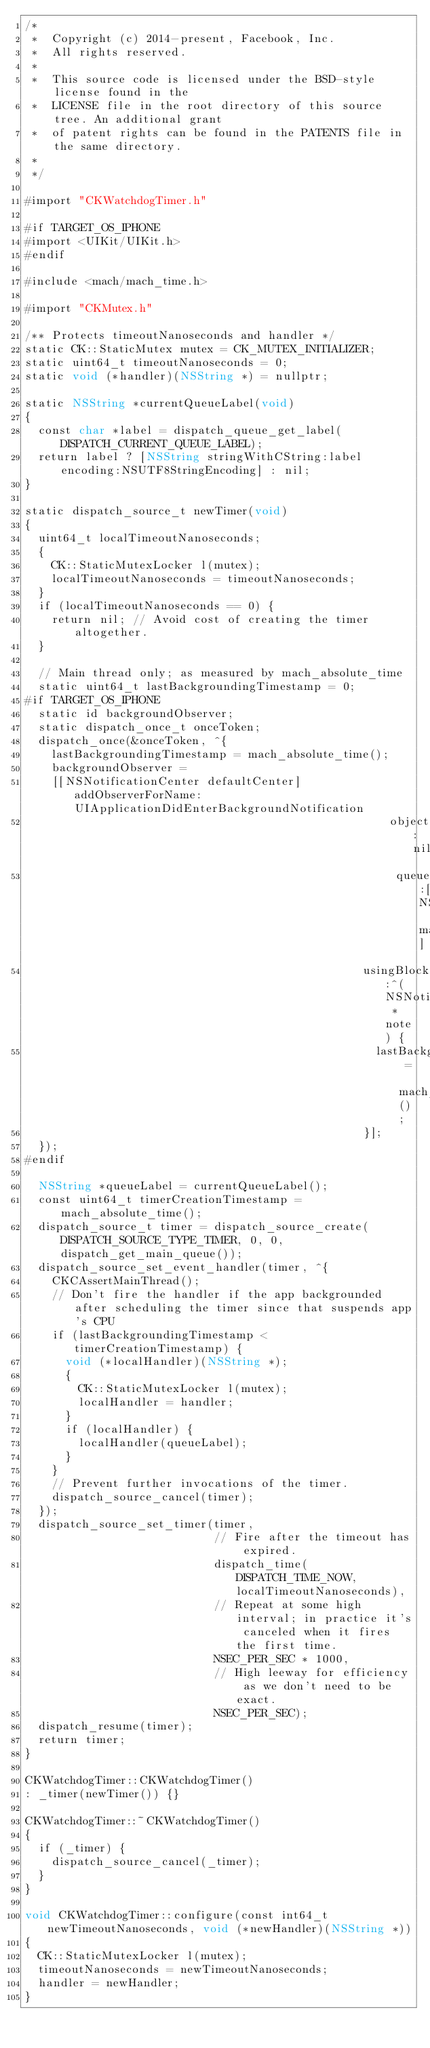<code> <loc_0><loc_0><loc_500><loc_500><_ObjectiveC_>/*
 *  Copyright (c) 2014-present, Facebook, Inc.
 *  All rights reserved.
 *
 *  This source code is licensed under the BSD-style license found in the
 *  LICENSE file in the root directory of this source tree. An additional grant
 *  of patent rights can be found in the PATENTS file in the same directory.
 *
 */

#import "CKWatchdogTimer.h"

#if TARGET_OS_IPHONE
#import <UIKit/UIKit.h>
#endif

#include <mach/mach_time.h>

#import "CKMutex.h"

/** Protects timeoutNanoseconds and handler */
static CK::StaticMutex mutex = CK_MUTEX_INITIALIZER;
static uint64_t timeoutNanoseconds = 0;
static void (*handler)(NSString *) = nullptr;

static NSString *currentQueueLabel(void)
{
  const char *label = dispatch_queue_get_label(DISPATCH_CURRENT_QUEUE_LABEL);
  return label ? [NSString stringWithCString:label encoding:NSUTF8StringEncoding] : nil;
}

static dispatch_source_t newTimer(void)
{
  uint64_t localTimeoutNanoseconds;
  {
    CK::StaticMutexLocker l(mutex);
    localTimeoutNanoseconds = timeoutNanoseconds;
  }
  if (localTimeoutNanoseconds == 0) {
    return nil; // Avoid cost of creating the timer altogether.
  }

  // Main thread only; as measured by mach_absolute_time
  static uint64_t lastBackgroundingTimestamp = 0;
#if TARGET_OS_IPHONE
  static id backgroundObserver;
  static dispatch_once_t onceToken;
  dispatch_once(&onceToken, ^{
    lastBackgroundingTimestamp = mach_absolute_time();
    backgroundObserver =
    [[NSNotificationCenter defaultCenter] addObserverForName:UIApplicationDidEnterBackgroundNotification
                                                      object:nil
                                                       queue:[NSOperationQueue mainQueue]
                                                  usingBlock:^(NSNotification *note) {
                                                    lastBackgroundingTimestamp = mach_absolute_time();
                                                  }];
  });
#endif
  
  NSString *queueLabel = currentQueueLabel();
  const uint64_t timerCreationTimestamp = mach_absolute_time();
  dispatch_source_t timer = dispatch_source_create(DISPATCH_SOURCE_TYPE_TIMER, 0, 0, dispatch_get_main_queue());
  dispatch_source_set_event_handler(timer, ^{
    CKCAssertMainThread();
    // Don't fire the handler if the app backgrounded after scheduling the timer since that suspends app's CPU
    if (lastBackgroundingTimestamp < timerCreationTimestamp) {
      void (*localHandler)(NSString *);
      {
        CK::StaticMutexLocker l(mutex);
        localHandler = handler;
      }
      if (localHandler) {
        localHandler(queueLabel);
      }
    }
    // Prevent further invocations of the timer.
    dispatch_source_cancel(timer);
  });
  dispatch_source_set_timer(timer,
                            // Fire after the timeout has expired.
                            dispatch_time(DISPATCH_TIME_NOW, localTimeoutNanoseconds),
                            // Repeat at some high interval; in practice it's canceled when it fires the first time.
                            NSEC_PER_SEC * 1000,
                            // High leeway for efficiency as we don't need to be exact.
                            NSEC_PER_SEC);
  dispatch_resume(timer);
  return timer;
}

CKWatchdogTimer::CKWatchdogTimer()
: _timer(newTimer()) {}

CKWatchdogTimer::~CKWatchdogTimer()
{
  if (_timer) {
    dispatch_source_cancel(_timer);
  }
}

void CKWatchdogTimer::configure(const int64_t newTimeoutNanoseconds, void (*newHandler)(NSString *))
{
  CK::StaticMutexLocker l(mutex);
  timeoutNanoseconds = newTimeoutNanoseconds;
  handler = newHandler;
}
</code> 